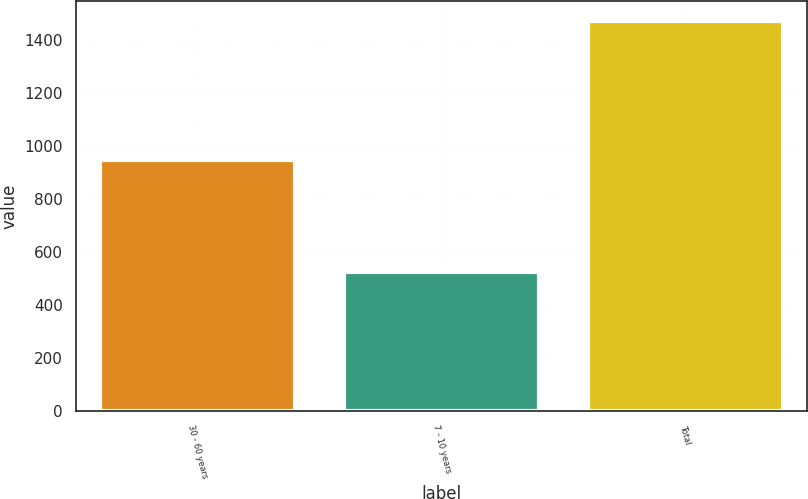<chart> <loc_0><loc_0><loc_500><loc_500><bar_chart><fcel>30 - 60 years<fcel>7 - 10 years<fcel>Total<nl><fcel>947<fcel>524<fcel>1471<nl></chart> 